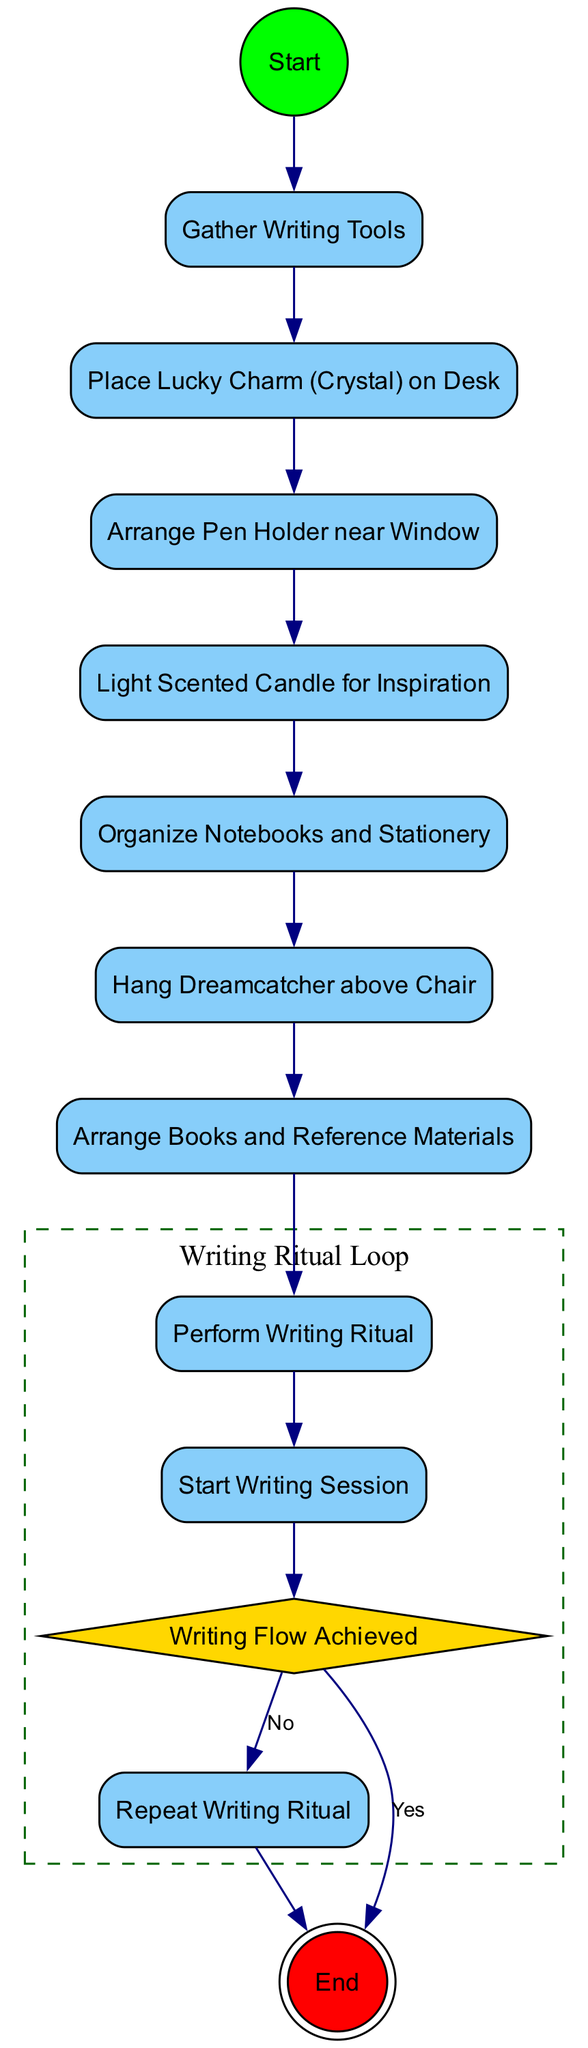What is the first activity in the diagram? The diagram starts with an initial node labeled "Start". This indicates the beginning of the activity flow.
Answer: Start How many action activities are there in total? By examining the diagram, it can be counted that there are eight action activities listed: "Gather Writing Tools," "Place Lucky Charm (Crystal) on Desk," "Arrange Pen Holder near Window," "Light Scented Candle for Inspiration," "Organize Notebooks and Stationery," "Hang Dreamcatcher above Chair," "Arrange Books and Reference Materials," "Perform Writing Ritual." Totaling these gives eight action activities.
Answer: 8 What decision point follows the "Start Writing Session"? The decision point that follows "Start Writing Session" is "Writing Flow Achieved". This is indicated as a point where the flow can take different paths based on whether the writing flow is achieved or not.
Answer: Writing Flow Achieved What happens if "Writing Flow Achieved" is answered with "No"? If the answer to "Writing Flow Achieved" is "No", the flow goes to "Repeat Writing Ritual", indicating that the writing ritual will be performed again until the flow is achieved. This illustrates the iterative nature of the writing process in seeking inspiration.
Answer: Repeat Writing Ritual How many final activities are presented in the diagram? There is only one final activity in the diagram, which is indicated by the doublecircle shape, labeled "End". This denotes the conclusion of the activity sequence.
Answer: 1 What is the relationship between "Perform Writing Ritual" and "Start Writing Session"? The activity "Perform Writing Ritual" directly precedes "Start Writing Session", indicating that the writing session cannot begin without first performing the writing ritual. This establishes a clear sequence in the process.
Answer: Perform Writing Ritual Which activity can be interrupted if writing flow is not achieved? If writing flow is not achieved after "Start Writing Session," the process can be interrupted to return to "Repeat Writing Ritual". This highlights flexibility in the writing process, allowing for adjustments to seek inspiration.
Answer: Repeat Writing Ritual What is the last action taken before reaching the "End"? The last action taken before reaching the "End" is "Writing Flow Achieved," which determines whether to conclude or repeat the writing ritual based on the achieved flow. This signifies a significant decision point in the writing process.
Answer: Writing Flow Achieved 